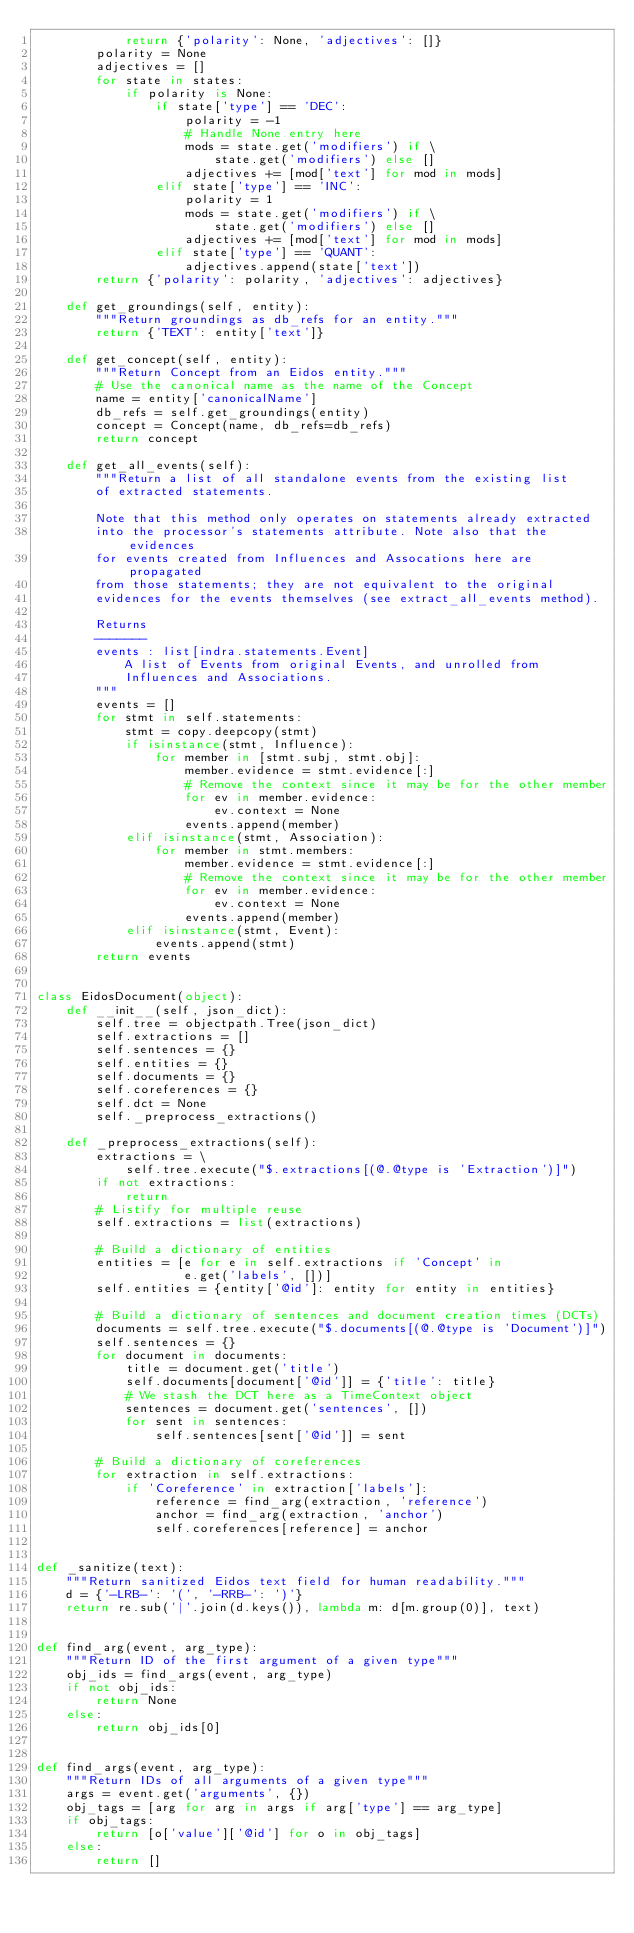Convert code to text. <code><loc_0><loc_0><loc_500><loc_500><_Python_>            return {'polarity': None, 'adjectives': []}
        polarity = None
        adjectives = []
        for state in states:
            if polarity is None:
                if state['type'] == 'DEC':
                    polarity = -1
                    # Handle None entry here
                    mods = state.get('modifiers') if \
                        state.get('modifiers') else []
                    adjectives += [mod['text'] for mod in mods]
                elif state['type'] == 'INC':
                    polarity = 1
                    mods = state.get('modifiers') if \
                        state.get('modifiers') else []
                    adjectives += [mod['text'] for mod in mods]
                elif state['type'] == 'QUANT':
                    adjectives.append(state['text'])
        return {'polarity': polarity, 'adjectives': adjectives}

    def get_groundings(self, entity):
        """Return groundings as db_refs for an entity."""
        return {'TEXT': entity['text']}

    def get_concept(self, entity):
        """Return Concept from an Eidos entity."""
        # Use the canonical name as the name of the Concept
        name = entity['canonicalName']
        db_refs = self.get_groundings(entity)
        concept = Concept(name, db_refs=db_refs)
        return concept

    def get_all_events(self):
        """Return a list of all standalone events from the existing list
        of extracted statements.

        Note that this method only operates on statements already extracted
        into the processor's statements attribute. Note also that the evidences
        for events created from Influences and Assocations here are propagated
        from those statements; they are not equivalent to the original
        evidences for the events themselves (see extract_all_events method).

        Returns
        -------
        events : list[indra.statements.Event]
            A list of Events from original Events, and unrolled from
            Influences and Associations.
        """
        events = []
        for stmt in self.statements:
            stmt = copy.deepcopy(stmt)
            if isinstance(stmt, Influence):
                for member in [stmt.subj, stmt.obj]:
                    member.evidence = stmt.evidence[:]
                    # Remove the context since it may be for the other member
                    for ev in member.evidence:
                        ev.context = None
                    events.append(member)
            elif isinstance(stmt, Association):
                for member in stmt.members:
                    member.evidence = stmt.evidence[:]
                    # Remove the context since it may be for the other member
                    for ev in member.evidence:
                        ev.context = None
                    events.append(member)
            elif isinstance(stmt, Event):
                events.append(stmt)
        return events


class EidosDocument(object):
    def __init__(self, json_dict):
        self.tree = objectpath.Tree(json_dict)
        self.extractions = []
        self.sentences = {}
        self.entities = {}
        self.documents = {}
        self.coreferences = {}
        self.dct = None
        self._preprocess_extractions()

    def _preprocess_extractions(self):
        extractions = \
            self.tree.execute("$.extractions[(@.@type is 'Extraction')]")
        if not extractions:
            return
        # Listify for multiple reuse
        self.extractions = list(extractions)

        # Build a dictionary of entities
        entities = [e for e in self.extractions if 'Concept' in
                    e.get('labels', [])]
        self.entities = {entity['@id']: entity for entity in entities}

        # Build a dictionary of sentences and document creation times (DCTs)
        documents = self.tree.execute("$.documents[(@.@type is 'Document')]")
        self.sentences = {}
        for document in documents:
            title = document.get('title')
            self.documents[document['@id']] = {'title': title}
            # We stash the DCT here as a TimeContext object
            sentences = document.get('sentences', [])
            for sent in sentences:
                self.sentences[sent['@id']] = sent

        # Build a dictionary of coreferences
        for extraction in self.extractions:
            if 'Coreference' in extraction['labels']:
                reference = find_arg(extraction, 'reference')
                anchor = find_arg(extraction, 'anchor')
                self.coreferences[reference] = anchor


def _sanitize(text):
    """Return sanitized Eidos text field for human readability."""
    d = {'-LRB-': '(', '-RRB-': ')'}
    return re.sub('|'.join(d.keys()), lambda m: d[m.group(0)], text)


def find_arg(event, arg_type):
    """Return ID of the first argument of a given type"""
    obj_ids = find_args(event, arg_type)
    if not obj_ids:
        return None
    else:
        return obj_ids[0]


def find_args(event, arg_type):
    """Return IDs of all arguments of a given type"""
    args = event.get('arguments', {})
    obj_tags = [arg for arg in args if arg['type'] == arg_type]
    if obj_tags:
        return [o['value']['@id'] for o in obj_tags]
    else:
        return []
</code> 